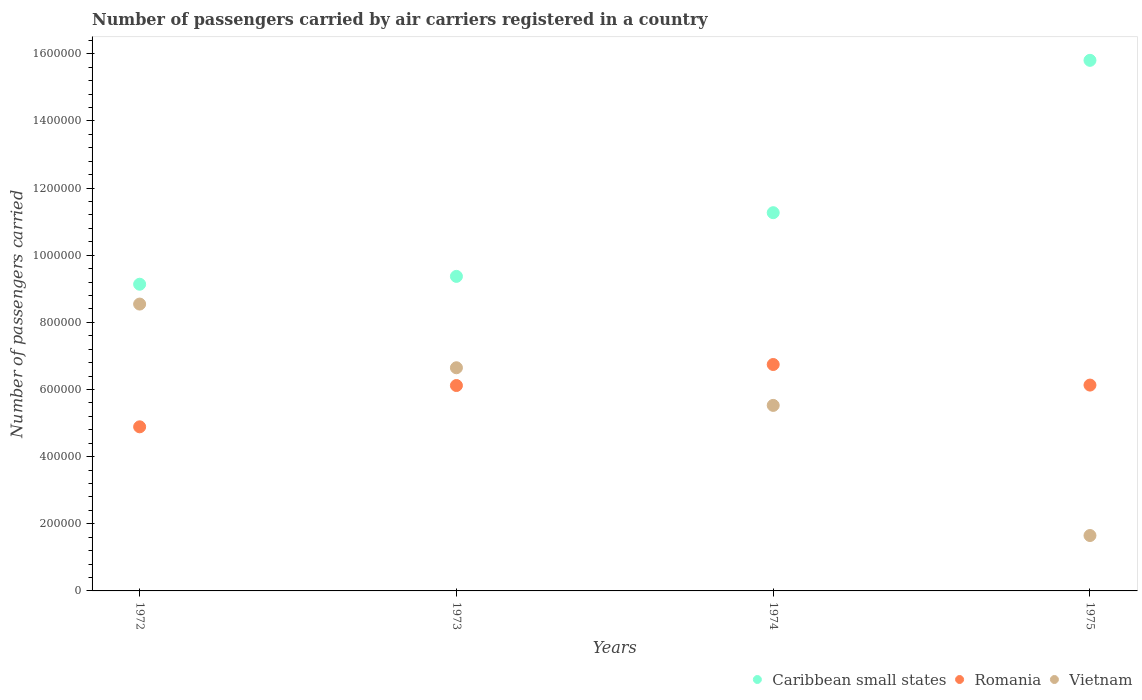Is the number of dotlines equal to the number of legend labels?
Your response must be concise. Yes. What is the number of passengers carried by air carriers in Vietnam in 1975?
Give a very brief answer. 1.65e+05. Across all years, what is the maximum number of passengers carried by air carriers in Romania?
Make the answer very short. 6.74e+05. Across all years, what is the minimum number of passengers carried by air carriers in Romania?
Your answer should be compact. 4.89e+05. In which year was the number of passengers carried by air carriers in Romania maximum?
Provide a succinct answer. 1974. What is the total number of passengers carried by air carriers in Vietnam in the graph?
Offer a very short reply. 2.24e+06. What is the difference between the number of passengers carried by air carriers in Caribbean small states in 1972 and that in 1973?
Offer a terse response. -2.34e+04. What is the difference between the number of passengers carried by air carriers in Vietnam in 1973 and the number of passengers carried by air carriers in Caribbean small states in 1972?
Your response must be concise. -2.49e+05. What is the average number of passengers carried by air carriers in Vietnam per year?
Keep it short and to the point. 5.59e+05. In the year 1972, what is the difference between the number of passengers carried by air carriers in Romania and number of passengers carried by air carriers in Vietnam?
Offer a very short reply. -3.66e+05. What is the ratio of the number of passengers carried by air carriers in Caribbean small states in 1972 to that in 1975?
Your answer should be compact. 0.58. Is the difference between the number of passengers carried by air carriers in Romania in 1972 and 1975 greater than the difference between the number of passengers carried by air carriers in Vietnam in 1972 and 1975?
Provide a succinct answer. No. What is the difference between the highest and the second highest number of passengers carried by air carriers in Caribbean small states?
Ensure brevity in your answer.  4.54e+05. What is the difference between the highest and the lowest number of passengers carried by air carriers in Romania?
Your answer should be compact. 1.86e+05. In how many years, is the number of passengers carried by air carriers in Romania greater than the average number of passengers carried by air carriers in Romania taken over all years?
Offer a terse response. 3. Is it the case that in every year, the sum of the number of passengers carried by air carriers in Romania and number of passengers carried by air carriers in Vietnam  is greater than the number of passengers carried by air carriers in Caribbean small states?
Keep it short and to the point. No. Does the number of passengers carried by air carriers in Vietnam monotonically increase over the years?
Your answer should be very brief. No. Is the number of passengers carried by air carriers in Vietnam strictly less than the number of passengers carried by air carriers in Caribbean small states over the years?
Your answer should be compact. Yes. How many years are there in the graph?
Your response must be concise. 4. Does the graph contain grids?
Ensure brevity in your answer.  No. Where does the legend appear in the graph?
Offer a terse response. Bottom right. How are the legend labels stacked?
Provide a short and direct response. Horizontal. What is the title of the graph?
Keep it short and to the point. Number of passengers carried by air carriers registered in a country. What is the label or title of the Y-axis?
Offer a very short reply. Number of passengers carried. What is the Number of passengers carried in Caribbean small states in 1972?
Provide a succinct answer. 9.14e+05. What is the Number of passengers carried of Romania in 1972?
Your answer should be compact. 4.89e+05. What is the Number of passengers carried in Vietnam in 1972?
Ensure brevity in your answer.  8.54e+05. What is the Number of passengers carried in Caribbean small states in 1973?
Your answer should be compact. 9.37e+05. What is the Number of passengers carried of Romania in 1973?
Your response must be concise. 6.12e+05. What is the Number of passengers carried of Vietnam in 1973?
Your answer should be compact. 6.65e+05. What is the Number of passengers carried in Caribbean small states in 1974?
Make the answer very short. 1.13e+06. What is the Number of passengers carried of Romania in 1974?
Your answer should be compact. 6.74e+05. What is the Number of passengers carried in Vietnam in 1974?
Your response must be concise. 5.53e+05. What is the Number of passengers carried in Caribbean small states in 1975?
Offer a terse response. 1.58e+06. What is the Number of passengers carried of Romania in 1975?
Provide a succinct answer. 6.13e+05. What is the Number of passengers carried in Vietnam in 1975?
Ensure brevity in your answer.  1.65e+05. Across all years, what is the maximum Number of passengers carried in Caribbean small states?
Give a very brief answer. 1.58e+06. Across all years, what is the maximum Number of passengers carried in Romania?
Make the answer very short. 6.74e+05. Across all years, what is the maximum Number of passengers carried of Vietnam?
Give a very brief answer. 8.54e+05. Across all years, what is the minimum Number of passengers carried of Caribbean small states?
Make the answer very short. 9.14e+05. Across all years, what is the minimum Number of passengers carried of Romania?
Provide a succinct answer. 4.89e+05. Across all years, what is the minimum Number of passengers carried of Vietnam?
Your answer should be very brief. 1.65e+05. What is the total Number of passengers carried in Caribbean small states in the graph?
Ensure brevity in your answer.  4.56e+06. What is the total Number of passengers carried of Romania in the graph?
Make the answer very short. 2.39e+06. What is the total Number of passengers carried of Vietnam in the graph?
Make the answer very short. 2.24e+06. What is the difference between the Number of passengers carried of Caribbean small states in 1972 and that in 1973?
Provide a succinct answer. -2.34e+04. What is the difference between the Number of passengers carried of Romania in 1972 and that in 1973?
Your answer should be compact. -1.23e+05. What is the difference between the Number of passengers carried in Vietnam in 1972 and that in 1973?
Your answer should be very brief. 1.90e+05. What is the difference between the Number of passengers carried of Caribbean small states in 1972 and that in 1974?
Make the answer very short. -2.13e+05. What is the difference between the Number of passengers carried of Romania in 1972 and that in 1974?
Offer a terse response. -1.86e+05. What is the difference between the Number of passengers carried in Vietnam in 1972 and that in 1974?
Offer a very short reply. 3.02e+05. What is the difference between the Number of passengers carried of Caribbean small states in 1972 and that in 1975?
Give a very brief answer. -6.67e+05. What is the difference between the Number of passengers carried in Romania in 1972 and that in 1975?
Ensure brevity in your answer.  -1.24e+05. What is the difference between the Number of passengers carried in Vietnam in 1972 and that in 1975?
Offer a very short reply. 6.89e+05. What is the difference between the Number of passengers carried in Caribbean small states in 1973 and that in 1974?
Keep it short and to the point. -1.90e+05. What is the difference between the Number of passengers carried in Romania in 1973 and that in 1974?
Your answer should be very brief. -6.26e+04. What is the difference between the Number of passengers carried in Vietnam in 1973 and that in 1974?
Give a very brief answer. 1.12e+05. What is the difference between the Number of passengers carried of Caribbean small states in 1973 and that in 1975?
Keep it short and to the point. -6.44e+05. What is the difference between the Number of passengers carried in Romania in 1973 and that in 1975?
Give a very brief answer. -1300. What is the difference between the Number of passengers carried of Vietnam in 1973 and that in 1975?
Ensure brevity in your answer.  5.00e+05. What is the difference between the Number of passengers carried in Caribbean small states in 1974 and that in 1975?
Your answer should be very brief. -4.54e+05. What is the difference between the Number of passengers carried in Romania in 1974 and that in 1975?
Your response must be concise. 6.13e+04. What is the difference between the Number of passengers carried of Vietnam in 1974 and that in 1975?
Provide a short and direct response. 3.88e+05. What is the difference between the Number of passengers carried in Caribbean small states in 1972 and the Number of passengers carried in Romania in 1973?
Offer a terse response. 3.02e+05. What is the difference between the Number of passengers carried in Caribbean small states in 1972 and the Number of passengers carried in Vietnam in 1973?
Make the answer very short. 2.49e+05. What is the difference between the Number of passengers carried of Romania in 1972 and the Number of passengers carried of Vietnam in 1973?
Offer a very short reply. -1.76e+05. What is the difference between the Number of passengers carried of Caribbean small states in 1972 and the Number of passengers carried of Romania in 1974?
Make the answer very short. 2.39e+05. What is the difference between the Number of passengers carried in Caribbean small states in 1972 and the Number of passengers carried in Vietnam in 1974?
Your response must be concise. 3.61e+05. What is the difference between the Number of passengers carried in Romania in 1972 and the Number of passengers carried in Vietnam in 1974?
Provide a short and direct response. -6.38e+04. What is the difference between the Number of passengers carried in Caribbean small states in 1972 and the Number of passengers carried in Romania in 1975?
Ensure brevity in your answer.  3.00e+05. What is the difference between the Number of passengers carried in Caribbean small states in 1972 and the Number of passengers carried in Vietnam in 1975?
Provide a succinct answer. 7.48e+05. What is the difference between the Number of passengers carried in Romania in 1972 and the Number of passengers carried in Vietnam in 1975?
Your answer should be compact. 3.24e+05. What is the difference between the Number of passengers carried in Caribbean small states in 1973 and the Number of passengers carried in Romania in 1974?
Your answer should be compact. 2.62e+05. What is the difference between the Number of passengers carried in Caribbean small states in 1973 and the Number of passengers carried in Vietnam in 1974?
Offer a terse response. 3.84e+05. What is the difference between the Number of passengers carried of Romania in 1973 and the Number of passengers carried of Vietnam in 1974?
Your answer should be very brief. 5.92e+04. What is the difference between the Number of passengers carried of Caribbean small states in 1973 and the Number of passengers carried of Romania in 1975?
Your response must be concise. 3.24e+05. What is the difference between the Number of passengers carried in Caribbean small states in 1973 and the Number of passengers carried in Vietnam in 1975?
Offer a terse response. 7.72e+05. What is the difference between the Number of passengers carried in Romania in 1973 and the Number of passengers carried in Vietnam in 1975?
Your answer should be very brief. 4.47e+05. What is the difference between the Number of passengers carried of Caribbean small states in 1974 and the Number of passengers carried of Romania in 1975?
Provide a succinct answer. 5.14e+05. What is the difference between the Number of passengers carried of Caribbean small states in 1974 and the Number of passengers carried of Vietnam in 1975?
Provide a short and direct response. 9.62e+05. What is the difference between the Number of passengers carried of Romania in 1974 and the Number of passengers carried of Vietnam in 1975?
Your answer should be very brief. 5.09e+05. What is the average Number of passengers carried of Caribbean small states per year?
Provide a short and direct response. 1.14e+06. What is the average Number of passengers carried in Romania per year?
Keep it short and to the point. 5.97e+05. What is the average Number of passengers carried of Vietnam per year?
Give a very brief answer. 5.59e+05. In the year 1972, what is the difference between the Number of passengers carried of Caribbean small states and Number of passengers carried of Romania?
Make the answer very short. 4.25e+05. In the year 1972, what is the difference between the Number of passengers carried of Caribbean small states and Number of passengers carried of Vietnam?
Provide a succinct answer. 5.91e+04. In the year 1972, what is the difference between the Number of passengers carried in Romania and Number of passengers carried in Vietnam?
Your response must be concise. -3.66e+05. In the year 1973, what is the difference between the Number of passengers carried in Caribbean small states and Number of passengers carried in Romania?
Your response must be concise. 3.25e+05. In the year 1973, what is the difference between the Number of passengers carried in Caribbean small states and Number of passengers carried in Vietnam?
Offer a very short reply. 2.72e+05. In the year 1973, what is the difference between the Number of passengers carried of Romania and Number of passengers carried of Vietnam?
Provide a short and direct response. -5.29e+04. In the year 1974, what is the difference between the Number of passengers carried of Caribbean small states and Number of passengers carried of Romania?
Make the answer very short. 4.52e+05. In the year 1974, what is the difference between the Number of passengers carried of Caribbean small states and Number of passengers carried of Vietnam?
Provide a succinct answer. 5.74e+05. In the year 1974, what is the difference between the Number of passengers carried of Romania and Number of passengers carried of Vietnam?
Provide a short and direct response. 1.22e+05. In the year 1975, what is the difference between the Number of passengers carried in Caribbean small states and Number of passengers carried in Romania?
Keep it short and to the point. 9.67e+05. In the year 1975, what is the difference between the Number of passengers carried of Caribbean small states and Number of passengers carried of Vietnam?
Give a very brief answer. 1.42e+06. In the year 1975, what is the difference between the Number of passengers carried in Romania and Number of passengers carried in Vietnam?
Provide a short and direct response. 4.48e+05. What is the ratio of the Number of passengers carried in Caribbean small states in 1972 to that in 1973?
Keep it short and to the point. 0.97. What is the ratio of the Number of passengers carried in Romania in 1972 to that in 1973?
Provide a short and direct response. 0.8. What is the ratio of the Number of passengers carried of Vietnam in 1972 to that in 1973?
Keep it short and to the point. 1.29. What is the ratio of the Number of passengers carried of Caribbean small states in 1972 to that in 1974?
Give a very brief answer. 0.81. What is the ratio of the Number of passengers carried of Romania in 1972 to that in 1974?
Your answer should be very brief. 0.72. What is the ratio of the Number of passengers carried in Vietnam in 1972 to that in 1974?
Keep it short and to the point. 1.55. What is the ratio of the Number of passengers carried in Caribbean small states in 1972 to that in 1975?
Offer a very short reply. 0.58. What is the ratio of the Number of passengers carried in Romania in 1972 to that in 1975?
Make the answer very short. 0.8. What is the ratio of the Number of passengers carried in Vietnam in 1972 to that in 1975?
Keep it short and to the point. 5.18. What is the ratio of the Number of passengers carried of Caribbean small states in 1973 to that in 1974?
Keep it short and to the point. 0.83. What is the ratio of the Number of passengers carried of Romania in 1973 to that in 1974?
Give a very brief answer. 0.91. What is the ratio of the Number of passengers carried in Vietnam in 1973 to that in 1974?
Keep it short and to the point. 1.2. What is the ratio of the Number of passengers carried in Caribbean small states in 1973 to that in 1975?
Your response must be concise. 0.59. What is the ratio of the Number of passengers carried in Romania in 1973 to that in 1975?
Provide a succinct answer. 1. What is the ratio of the Number of passengers carried of Vietnam in 1973 to that in 1975?
Provide a short and direct response. 4.03. What is the ratio of the Number of passengers carried of Caribbean small states in 1974 to that in 1975?
Make the answer very short. 0.71. What is the ratio of the Number of passengers carried of Romania in 1974 to that in 1975?
Provide a succinct answer. 1.1. What is the ratio of the Number of passengers carried in Vietnam in 1974 to that in 1975?
Your response must be concise. 3.35. What is the difference between the highest and the second highest Number of passengers carried in Caribbean small states?
Give a very brief answer. 4.54e+05. What is the difference between the highest and the second highest Number of passengers carried of Romania?
Give a very brief answer. 6.13e+04. What is the difference between the highest and the second highest Number of passengers carried of Vietnam?
Offer a very short reply. 1.90e+05. What is the difference between the highest and the lowest Number of passengers carried in Caribbean small states?
Your answer should be compact. 6.67e+05. What is the difference between the highest and the lowest Number of passengers carried of Romania?
Your answer should be compact. 1.86e+05. What is the difference between the highest and the lowest Number of passengers carried of Vietnam?
Your answer should be compact. 6.89e+05. 